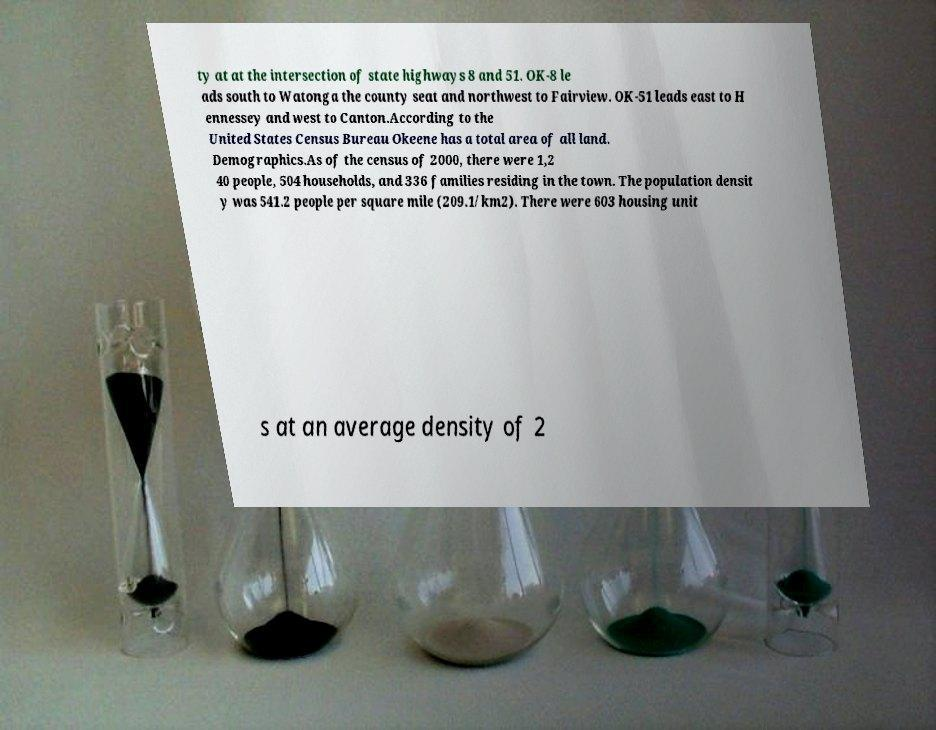Could you assist in decoding the text presented in this image and type it out clearly? ty at at the intersection of state highways 8 and 51. OK-8 le ads south to Watonga the county seat and northwest to Fairview. OK-51 leads east to H ennessey and west to Canton.According to the United States Census Bureau Okeene has a total area of all land. Demographics.As of the census of 2000, there were 1,2 40 people, 504 households, and 336 families residing in the town. The population densit y was 541.2 people per square mile (209.1/km2). There were 603 housing unit s at an average density of 2 